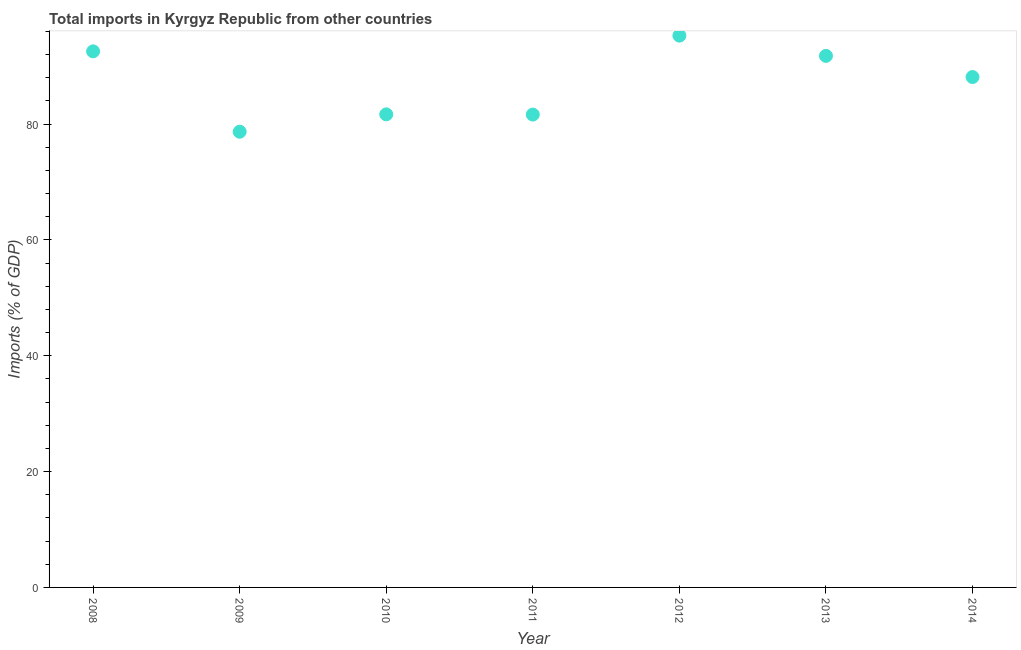What is the total imports in 2014?
Provide a succinct answer. 88.12. Across all years, what is the maximum total imports?
Provide a short and direct response. 95.27. Across all years, what is the minimum total imports?
Offer a very short reply. 78.68. In which year was the total imports maximum?
Your answer should be compact. 2012. In which year was the total imports minimum?
Your response must be concise. 2009. What is the sum of the total imports?
Make the answer very short. 609.73. What is the difference between the total imports in 2009 and 2013?
Offer a terse response. -13.1. What is the average total imports per year?
Provide a short and direct response. 87.1. What is the median total imports?
Ensure brevity in your answer.  88.12. In how many years, is the total imports greater than 56 %?
Offer a very short reply. 7. What is the ratio of the total imports in 2012 to that in 2013?
Your response must be concise. 1.04. Is the difference between the total imports in 2008 and 2012 greater than the difference between any two years?
Your answer should be very brief. No. What is the difference between the highest and the second highest total imports?
Ensure brevity in your answer.  2.71. What is the difference between the highest and the lowest total imports?
Offer a terse response. 16.59. In how many years, is the total imports greater than the average total imports taken over all years?
Give a very brief answer. 4. What is the difference between two consecutive major ticks on the Y-axis?
Your response must be concise. 20. Does the graph contain any zero values?
Provide a short and direct response. No. Does the graph contain grids?
Your answer should be very brief. No. What is the title of the graph?
Offer a terse response. Total imports in Kyrgyz Republic from other countries. What is the label or title of the Y-axis?
Offer a very short reply. Imports (% of GDP). What is the Imports (% of GDP) in 2008?
Make the answer very short. 92.56. What is the Imports (% of GDP) in 2009?
Your response must be concise. 78.68. What is the Imports (% of GDP) in 2010?
Make the answer very short. 81.68. What is the Imports (% of GDP) in 2011?
Provide a short and direct response. 81.64. What is the Imports (% of GDP) in 2012?
Give a very brief answer. 95.27. What is the Imports (% of GDP) in 2013?
Your response must be concise. 91.78. What is the Imports (% of GDP) in 2014?
Offer a terse response. 88.12. What is the difference between the Imports (% of GDP) in 2008 and 2009?
Your response must be concise. 13.88. What is the difference between the Imports (% of GDP) in 2008 and 2010?
Ensure brevity in your answer.  10.88. What is the difference between the Imports (% of GDP) in 2008 and 2011?
Make the answer very short. 10.92. What is the difference between the Imports (% of GDP) in 2008 and 2012?
Provide a succinct answer. -2.71. What is the difference between the Imports (% of GDP) in 2008 and 2013?
Keep it short and to the point. 0.78. What is the difference between the Imports (% of GDP) in 2008 and 2014?
Your response must be concise. 4.43. What is the difference between the Imports (% of GDP) in 2009 and 2010?
Make the answer very short. -3. What is the difference between the Imports (% of GDP) in 2009 and 2011?
Offer a very short reply. -2.96. What is the difference between the Imports (% of GDP) in 2009 and 2012?
Your response must be concise. -16.59. What is the difference between the Imports (% of GDP) in 2009 and 2013?
Provide a succinct answer. -13.1. What is the difference between the Imports (% of GDP) in 2009 and 2014?
Make the answer very short. -9.44. What is the difference between the Imports (% of GDP) in 2010 and 2011?
Provide a succinct answer. 0.04. What is the difference between the Imports (% of GDP) in 2010 and 2012?
Offer a terse response. -13.59. What is the difference between the Imports (% of GDP) in 2010 and 2013?
Your response must be concise. -10.1. What is the difference between the Imports (% of GDP) in 2010 and 2014?
Give a very brief answer. -6.44. What is the difference between the Imports (% of GDP) in 2011 and 2012?
Ensure brevity in your answer.  -13.63. What is the difference between the Imports (% of GDP) in 2011 and 2013?
Ensure brevity in your answer.  -10.14. What is the difference between the Imports (% of GDP) in 2011 and 2014?
Ensure brevity in your answer.  -6.48. What is the difference between the Imports (% of GDP) in 2012 and 2013?
Make the answer very short. 3.5. What is the difference between the Imports (% of GDP) in 2012 and 2014?
Give a very brief answer. 7.15. What is the difference between the Imports (% of GDP) in 2013 and 2014?
Provide a short and direct response. 3.65. What is the ratio of the Imports (% of GDP) in 2008 to that in 2009?
Give a very brief answer. 1.18. What is the ratio of the Imports (% of GDP) in 2008 to that in 2010?
Give a very brief answer. 1.13. What is the ratio of the Imports (% of GDP) in 2008 to that in 2011?
Offer a terse response. 1.13. What is the ratio of the Imports (% of GDP) in 2009 to that in 2010?
Make the answer very short. 0.96. What is the ratio of the Imports (% of GDP) in 2009 to that in 2012?
Your response must be concise. 0.83. What is the ratio of the Imports (% of GDP) in 2009 to that in 2013?
Offer a very short reply. 0.86. What is the ratio of the Imports (% of GDP) in 2009 to that in 2014?
Provide a succinct answer. 0.89. What is the ratio of the Imports (% of GDP) in 2010 to that in 2012?
Offer a very short reply. 0.86. What is the ratio of the Imports (% of GDP) in 2010 to that in 2013?
Offer a very short reply. 0.89. What is the ratio of the Imports (% of GDP) in 2010 to that in 2014?
Offer a very short reply. 0.93. What is the ratio of the Imports (% of GDP) in 2011 to that in 2012?
Give a very brief answer. 0.86. What is the ratio of the Imports (% of GDP) in 2011 to that in 2013?
Keep it short and to the point. 0.89. What is the ratio of the Imports (% of GDP) in 2011 to that in 2014?
Give a very brief answer. 0.93. What is the ratio of the Imports (% of GDP) in 2012 to that in 2013?
Keep it short and to the point. 1.04. What is the ratio of the Imports (% of GDP) in 2012 to that in 2014?
Provide a short and direct response. 1.08. What is the ratio of the Imports (% of GDP) in 2013 to that in 2014?
Offer a very short reply. 1.04. 